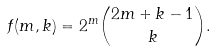Convert formula to latex. <formula><loc_0><loc_0><loc_500><loc_500>f ( m , k ) = 2 ^ { m } \binom { 2 m + k - 1 } { k } .</formula> 